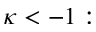<formula> <loc_0><loc_0><loc_500><loc_500>\kappa < - 1 \colon</formula> 